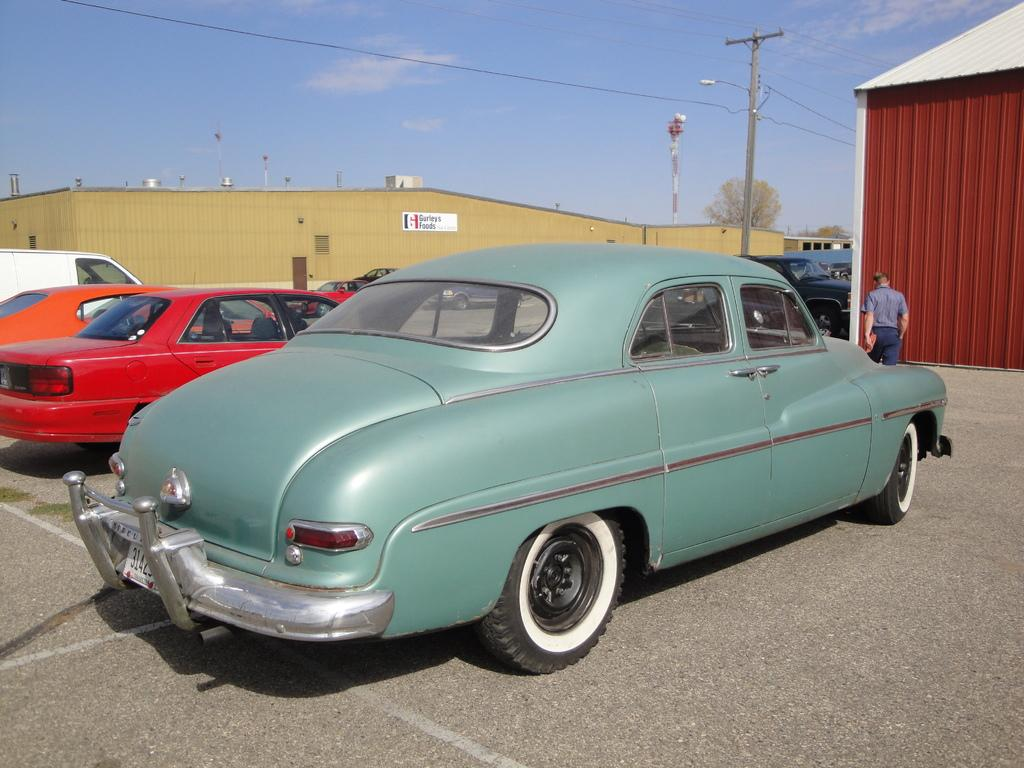What can be seen on the road in the image? There are vehicles on the road in the image. Can you describe the person in the image? There is a person standing in the image. What else can be seen in the image besides the vehicles and person? There are cables, a pole, sheds, and a tree visible in the image. What is visible in the background of the image? The sky is visible in the background of the image. What type of engine is visible in the image? There is no engine present in the image; it only shows vehicles on the road. Where is the hall located in the image? There is no hall present in the image. 